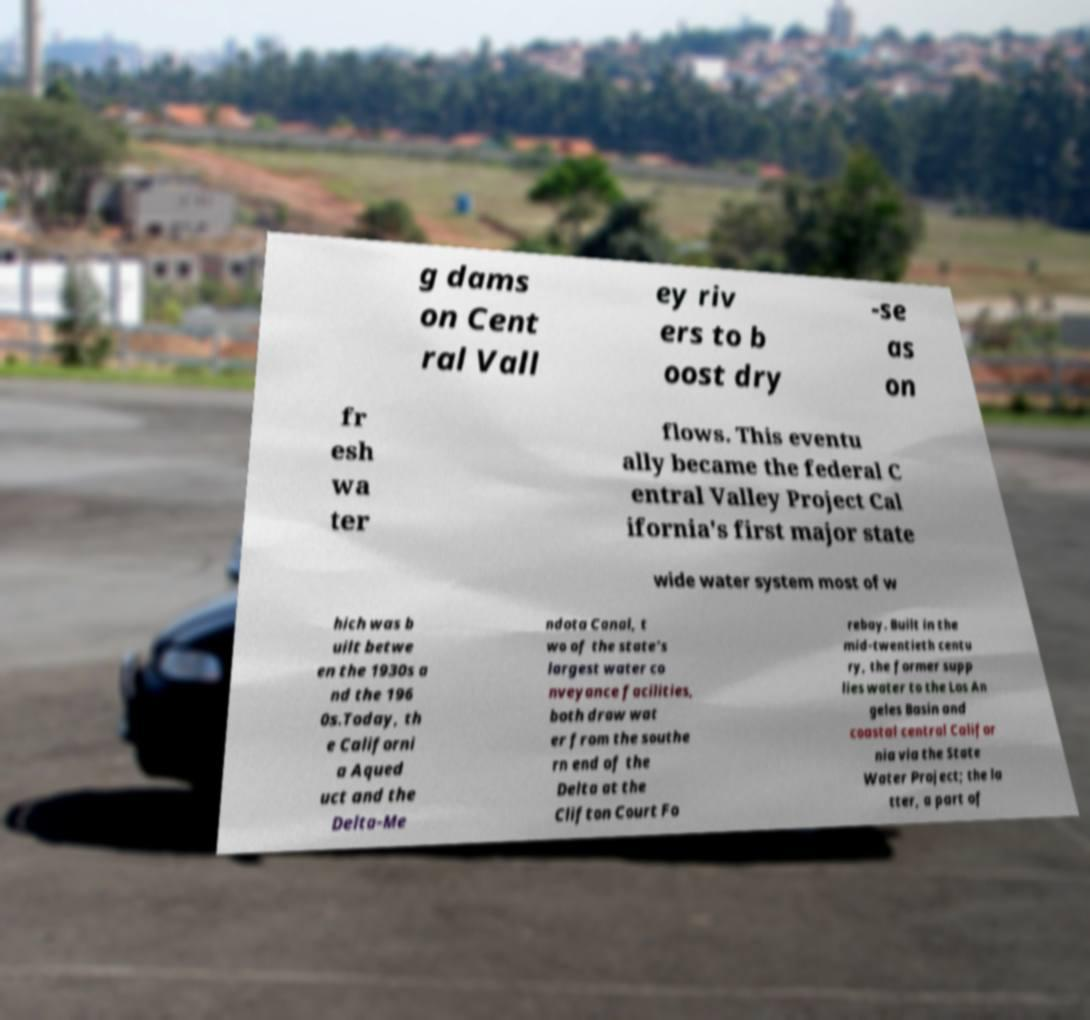For documentation purposes, I need the text within this image transcribed. Could you provide that? g dams on Cent ral Vall ey riv ers to b oost dry -se as on fr esh wa ter flows. This eventu ally became the federal C entral Valley Project Cal ifornia's first major state wide water system most of w hich was b uilt betwe en the 1930s a nd the 196 0s.Today, th e Californi a Aqued uct and the Delta-Me ndota Canal, t wo of the state's largest water co nveyance facilities, both draw wat er from the southe rn end of the Delta at the Clifton Court Fo rebay. Built in the mid-twentieth centu ry, the former supp lies water to the Los An geles Basin and coastal central Califor nia via the State Water Project; the la tter, a part of 